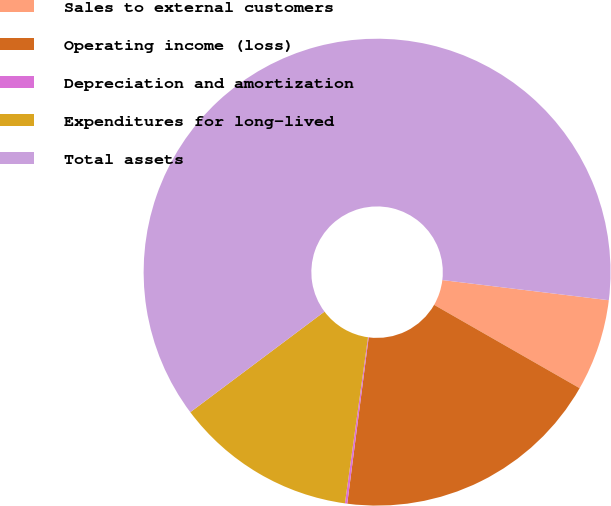<chart> <loc_0><loc_0><loc_500><loc_500><pie_chart><fcel>Sales to external customers<fcel>Operating income (loss)<fcel>Depreciation and amortization<fcel>Expenditures for long-lived<fcel>Total assets<nl><fcel>6.36%<fcel>18.76%<fcel>0.16%<fcel>12.56%<fcel>62.15%<nl></chart> 